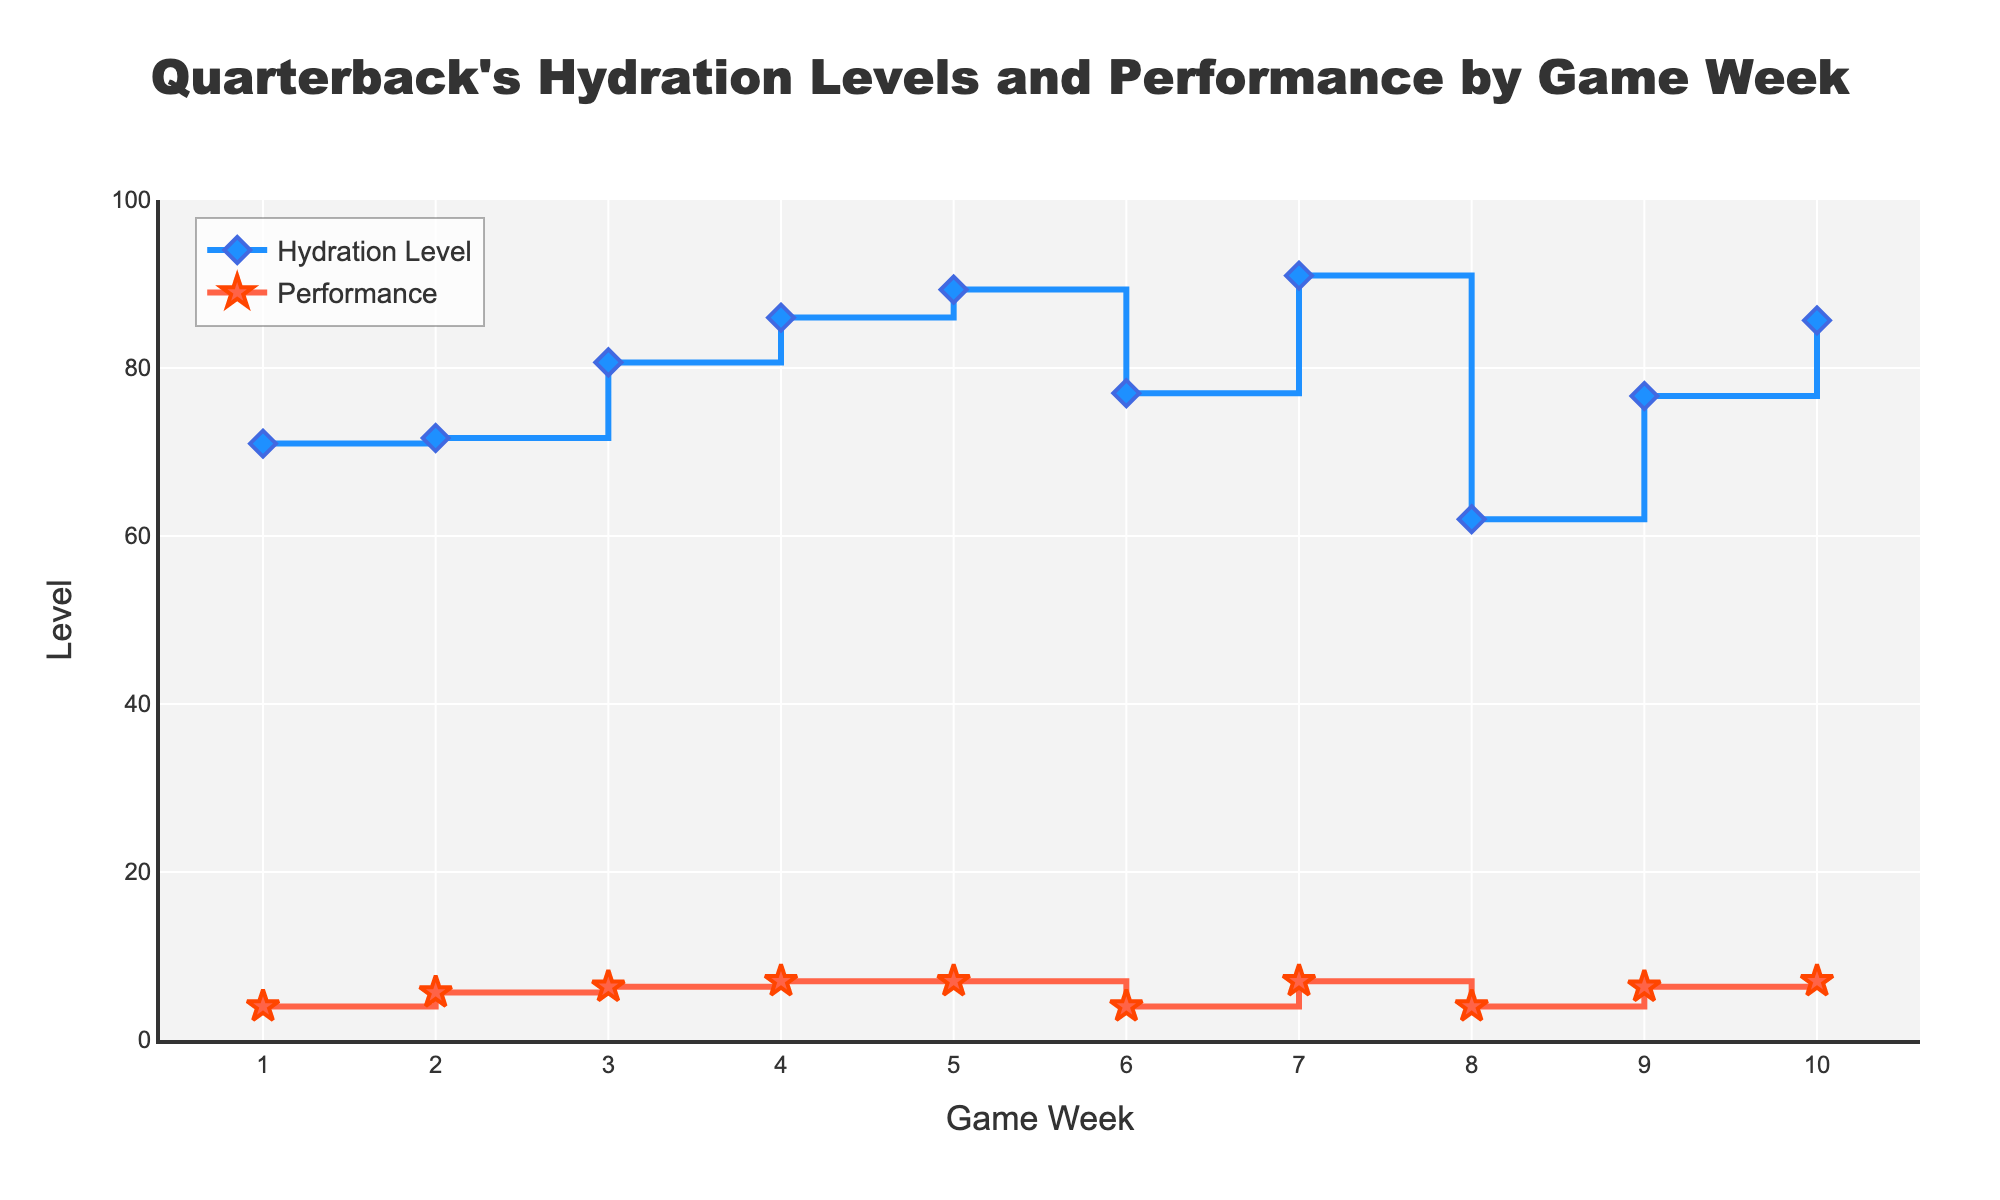What is the title of the plot? The title is located at the top of the plot, centered, and usually summarizes the main subject of the data presented. It reads "Quarterback's Hydration Levels and Performance by Game Week".
Answer: Quarterback's Hydration Levels and Performance by Game Week What are the two variables plotted on the y-axis? Inspecting the legend and the axis labels, the y-axis represents "Level" which includes "Hydration Level" and "LikertScalePerformance".
Answer: Hydration Level and Performance How many game weeks are shown on the x-axis? The x-axis is labeled "Game Week" and ranges from 1 to 10 as seen from the axis ticks. There are 10 game weeks.
Answer: 10 What is the average hydration level for Game Week 7? Locate the point for Game Week 7 on the blue "Hydration Level" line. It corresponds to a value of 91.
Answer: 91 In which game week is the highest average performance recorded? Look for the peak point on the red "Performance" line. The highest average performance is recorded in Game Week 5 with a performance score of 9.
Answer: Game Week 5 How does the average hydration level change from Game Week 6 to Game Week 7? Compare the hydration levels at Game Week 6 and 7 on the blue line. The hydration level increases from approximately 77 to 91.
Answer: It increases What is the average performance in Game Week 2? Find Game Week 2 on the red "Performance" line. The average performance is around 5.67 (approximately 6 when rounded).
Answer: 6 Between which game weeks is the smallest change in average hydration level observed? Inspect the blue "Hydration Level" line for the smallest vertical step. The smallest change appears between Game Weeks 3 and 4, where hydration levels are approximately 80 and 82.
Answer: Game Weeks 3 and 4 Does higher hydration correlate with higher performance according to the plot? Compare the general trends of the blue "Hydration Level" line and the red "Performance" line. Both lines trend upwards generally, indicating a positive correlation.
Answer: Yes, there is a positive correlation Which game week shows the largest discrepancy between hydration level and performance? Look for where the differences between the blue and red lines are the greatest. In Game Week 8, there is a notable gap with a high hydration level (around 63) but lower performance (around 4).
Answer: Game Week 8 